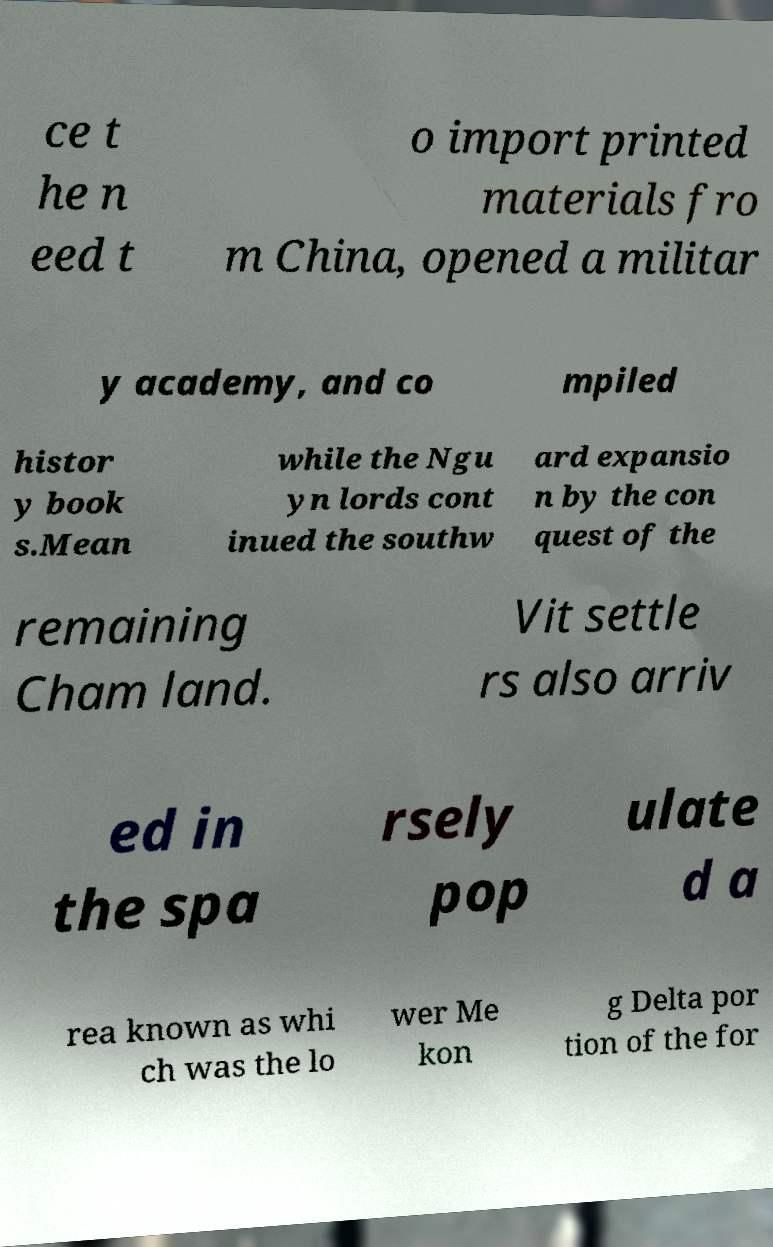Please identify and transcribe the text found in this image. ce t he n eed t o import printed materials fro m China, opened a militar y academy, and co mpiled histor y book s.Mean while the Ngu yn lords cont inued the southw ard expansio n by the con quest of the remaining Cham land. Vit settle rs also arriv ed in the spa rsely pop ulate d a rea known as whi ch was the lo wer Me kon g Delta por tion of the for 